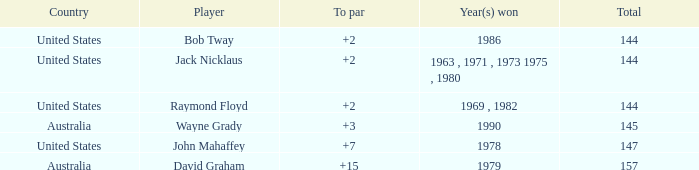What was the average round score of the player who won in 1978? 147.0. 